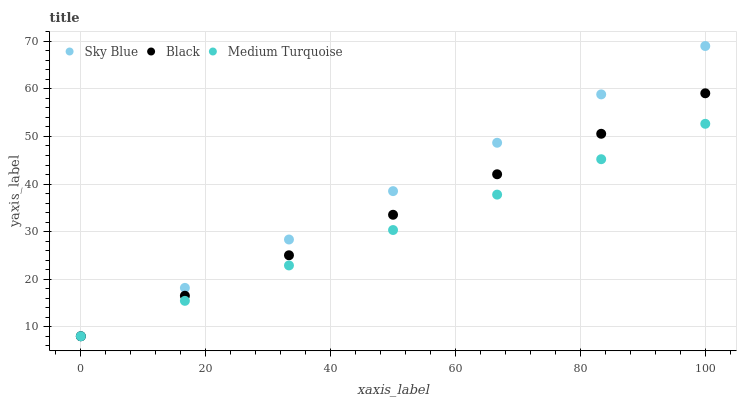Does Medium Turquoise have the minimum area under the curve?
Answer yes or no. Yes. Does Sky Blue have the maximum area under the curve?
Answer yes or no. Yes. Does Black have the minimum area under the curve?
Answer yes or no. No. Does Black have the maximum area under the curve?
Answer yes or no. No. Is Medium Turquoise the smoothest?
Answer yes or no. Yes. Is Sky Blue the roughest?
Answer yes or no. Yes. Is Black the smoothest?
Answer yes or no. No. Is Black the roughest?
Answer yes or no. No. Does Sky Blue have the lowest value?
Answer yes or no. Yes. Does Sky Blue have the highest value?
Answer yes or no. Yes. Does Black have the highest value?
Answer yes or no. No. Does Black intersect Sky Blue?
Answer yes or no. Yes. Is Black less than Sky Blue?
Answer yes or no. No. Is Black greater than Sky Blue?
Answer yes or no. No. 